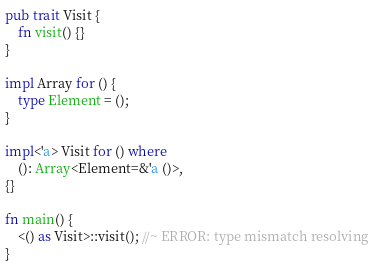Convert code to text. <code><loc_0><loc_0><loc_500><loc_500><_Rust_>
pub trait Visit {
    fn visit() {}
}

impl Array for () {
    type Element = ();
}

impl<'a> Visit for () where
    (): Array<Element=&'a ()>,
{}

fn main() {
    <() as Visit>::visit(); //~ ERROR: type mismatch resolving
}
</code> 